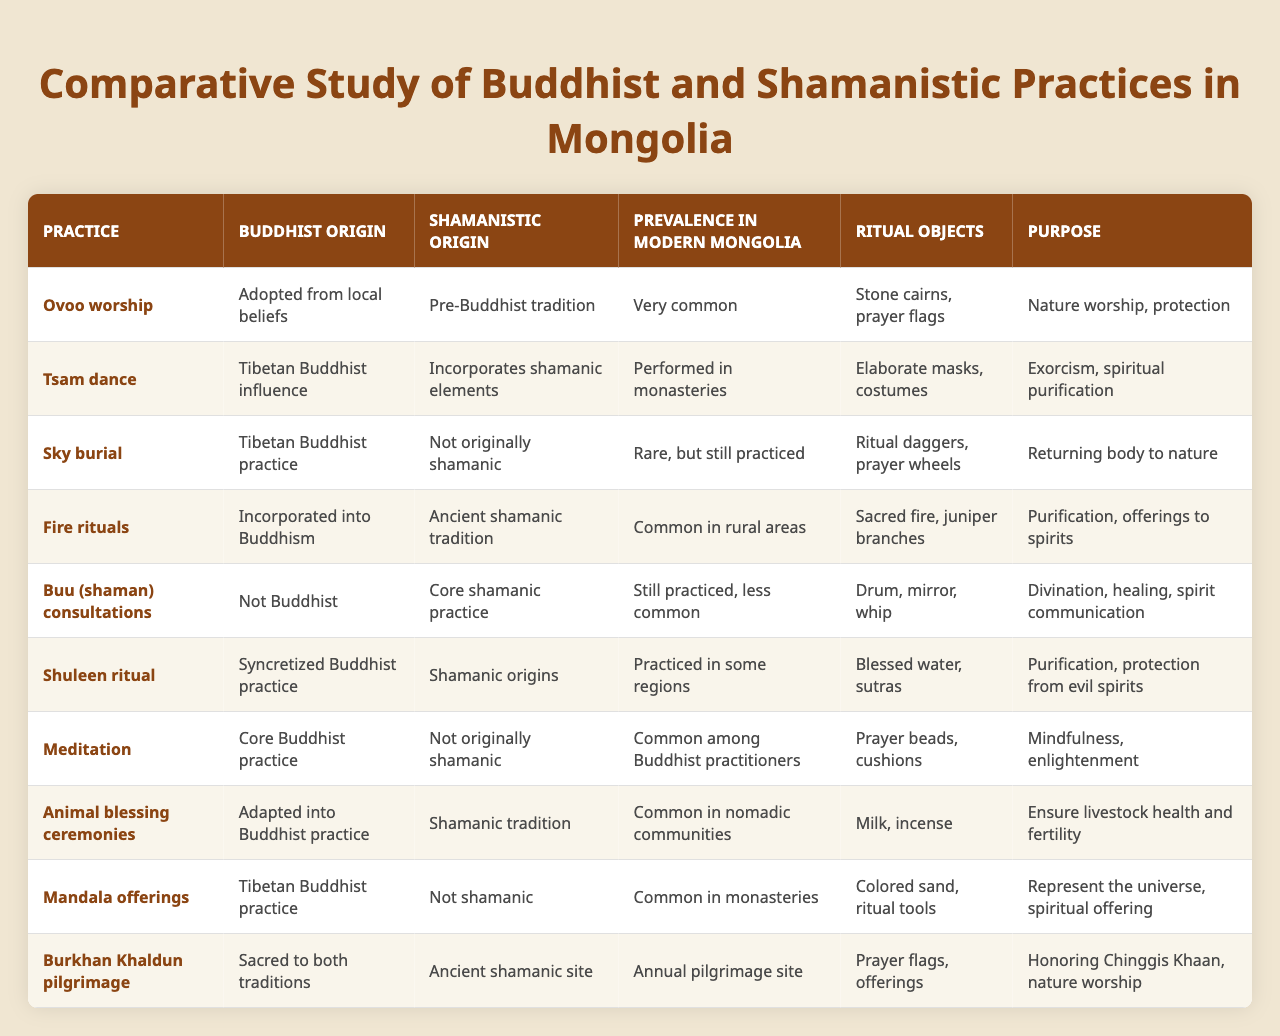What is the primary purpose of Ovoo worship? The purpose of Ovoo worship, as indicated in the table, is for nature worship and protection.
Answer: Nature worship, protection Which practice is very common in modern Mongolia and has shamanistic origins? The practice that is very common in modern Mongolia and has shamanistic origins is animal blessing ceremonies.
Answer: Animal blessing ceremonies Is the Tsam dance performed in monasteries? Yes, the table states that the Tsam dance is performed in monasteries.
Answer: Yes What are the ritual objects used for fire rituals? The ritual objects used for fire rituals include sacred fire and juniper branches, as listed in the table.
Answer: Sacred fire, juniper branches Which practice involves both Buddhist and shamanistic beliefs? The Burkhan Khaldun pilgrimage involves both Buddhist and shamanistic beliefs.
Answer: Burkhan Khaldun pilgrimage How prevalent is the practice of sky burial in modern Mongolia? Sky burial is categorized as rare but still practiced in modern Mongolia according to the table.
Answer: Rare, but still practiced Are Buu consultations primarily a Buddhist practice? No, Buu consultations are identified as a core shamanic practice, indicating they are not primarily Buddhist.
Answer: No What are the main purposes of the Shuleen ritual? The main purposes of the Shuleen ritual are purification and protection from evil spirits, as mentioned in the table.
Answer: Purification, protection from evil spirits Which practice has its origins in Tibetan Buddhism but incorporates shamanistic elements? The practice that has its origins in Tibetan Buddhism but incorporates shamanistic elements is the Tsam dance.
Answer: Tsam dance What is the primary purpose of animal blessing ceremonies? The primary purpose of animal blessing ceremonies is to ensure livestock health and fertility.
Answer: Ensure livestock health and fertility What is the relationship between meditation and shamanistic practices? Meditation is a core Buddhist practice and is noted in the table to be not originally shamanic, indicating a lack of direct connection to shamanistic practices.
Answer: Not originally shamanic 